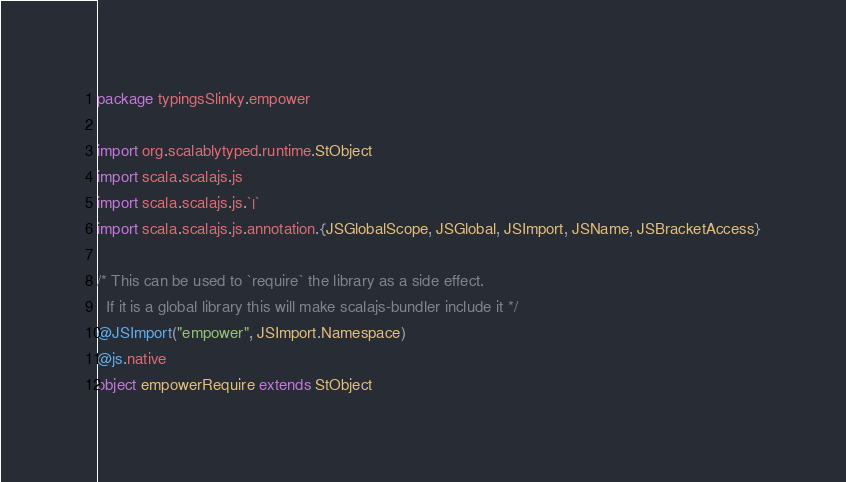<code> <loc_0><loc_0><loc_500><loc_500><_Scala_>package typingsSlinky.empower

import org.scalablytyped.runtime.StObject
import scala.scalajs.js
import scala.scalajs.js.`|`
import scala.scalajs.js.annotation.{JSGlobalScope, JSGlobal, JSImport, JSName, JSBracketAccess}

/* This can be used to `require` the library as a side effect.
  If it is a global library this will make scalajs-bundler include it */
@JSImport("empower", JSImport.Namespace)
@js.native
object empowerRequire extends StObject
</code> 